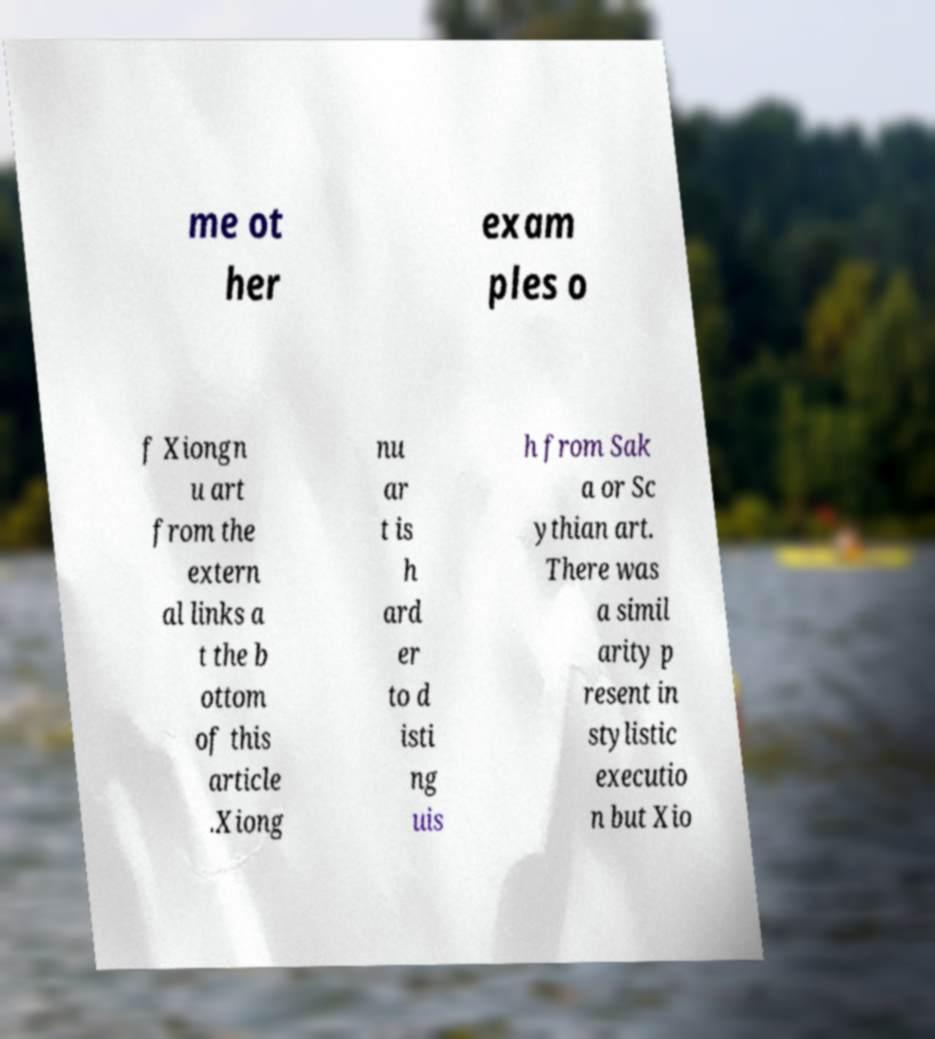There's text embedded in this image that I need extracted. Can you transcribe it verbatim? me ot her exam ples o f Xiongn u art from the extern al links a t the b ottom of this article .Xiong nu ar t is h ard er to d isti ng uis h from Sak a or Sc ythian art. There was a simil arity p resent in stylistic executio n but Xio 